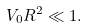Convert formula to latex. <formula><loc_0><loc_0><loc_500><loc_500>V _ { 0 } R ^ { 2 } \ll 1 .</formula> 